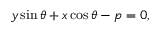Convert formula to latex. <formula><loc_0><loc_0><loc_500><loc_500>y \sin \theta + x \cos \theta - p = 0 ,</formula> 